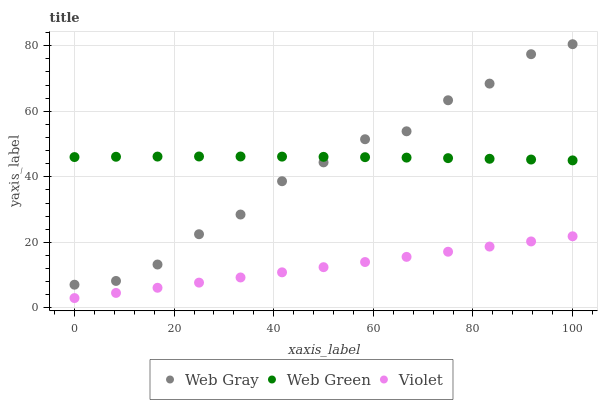Does Violet have the minimum area under the curve?
Answer yes or no. Yes. Does Web Green have the maximum area under the curve?
Answer yes or no. Yes. Does Web Green have the minimum area under the curve?
Answer yes or no. No. Does Violet have the maximum area under the curve?
Answer yes or no. No. Is Violet the smoothest?
Answer yes or no. Yes. Is Web Gray the roughest?
Answer yes or no. Yes. Is Web Green the smoothest?
Answer yes or no. No. Is Web Green the roughest?
Answer yes or no. No. Does Violet have the lowest value?
Answer yes or no. Yes. Does Web Green have the lowest value?
Answer yes or no. No. Does Web Gray have the highest value?
Answer yes or no. Yes. Does Web Green have the highest value?
Answer yes or no. No. Is Violet less than Web Gray?
Answer yes or no. Yes. Is Web Green greater than Violet?
Answer yes or no. Yes. Does Web Gray intersect Web Green?
Answer yes or no. Yes. Is Web Gray less than Web Green?
Answer yes or no. No. Is Web Gray greater than Web Green?
Answer yes or no. No. Does Violet intersect Web Gray?
Answer yes or no. No. 